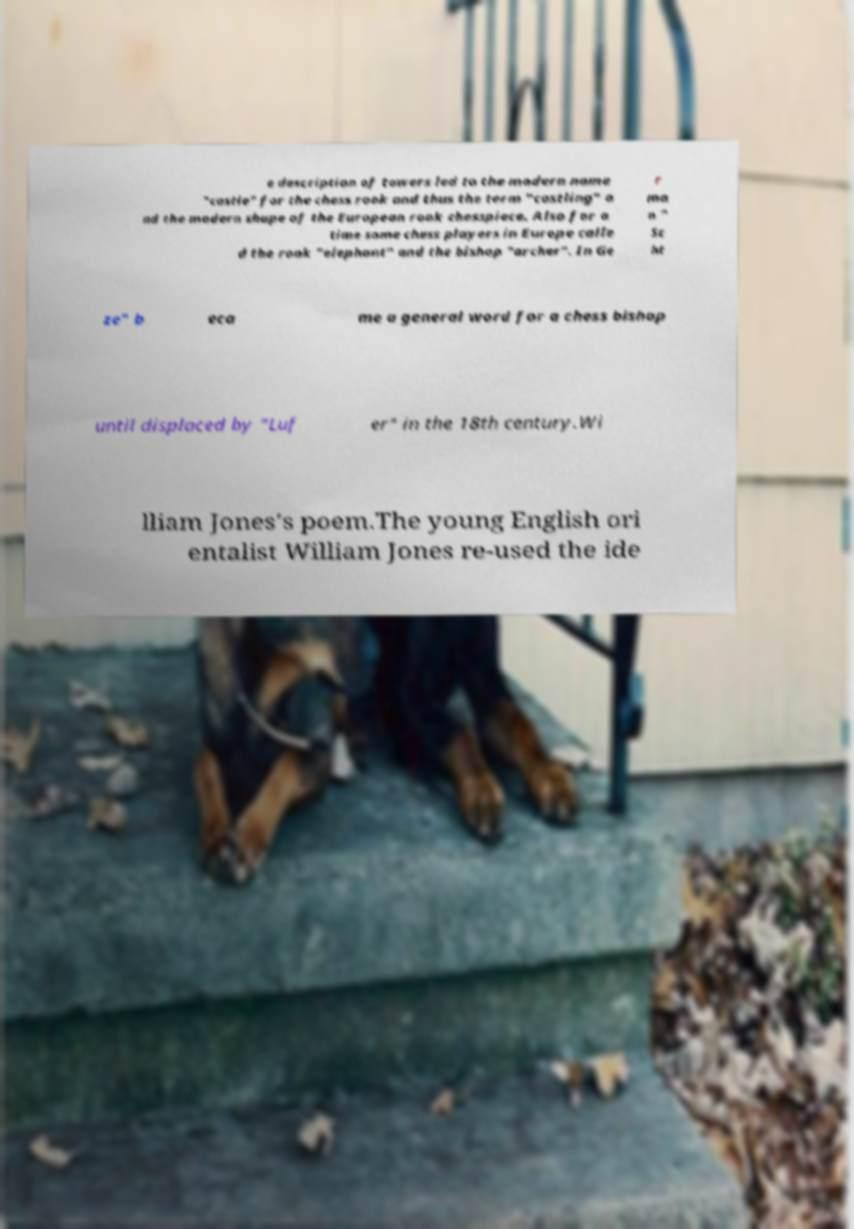I need the written content from this picture converted into text. Can you do that? e description of towers led to the modern name "castle" for the chess rook and thus the term "castling" a nd the modern shape of the European rook chesspiece. Also for a time some chess players in Europe calle d the rook "elephant" and the bishop "archer". In Ge r ma n " Sc ht ze" b eca me a general word for a chess bishop until displaced by "Luf er" in the 18th century.Wi lliam Jones's poem.The young English ori entalist William Jones re-used the ide 